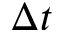<formula> <loc_0><loc_0><loc_500><loc_500>\Delta t</formula> 